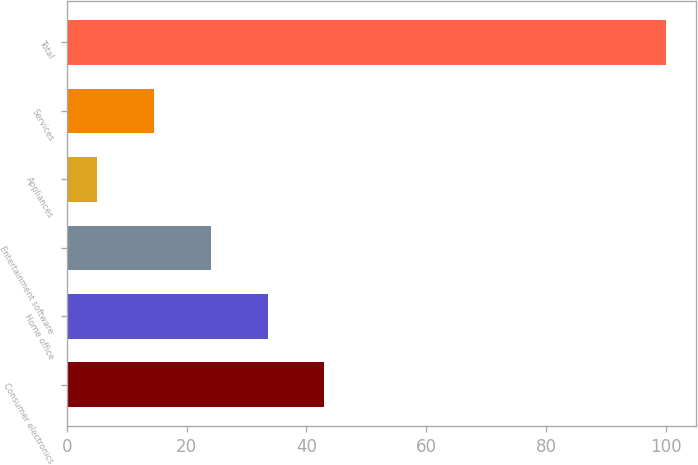Convert chart to OTSL. <chart><loc_0><loc_0><loc_500><loc_500><bar_chart><fcel>Consumer electronics<fcel>Home office<fcel>Entertainment software<fcel>Appliances<fcel>Services<fcel>Total<nl><fcel>43<fcel>33.5<fcel>24<fcel>5<fcel>14.5<fcel>100<nl></chart> 